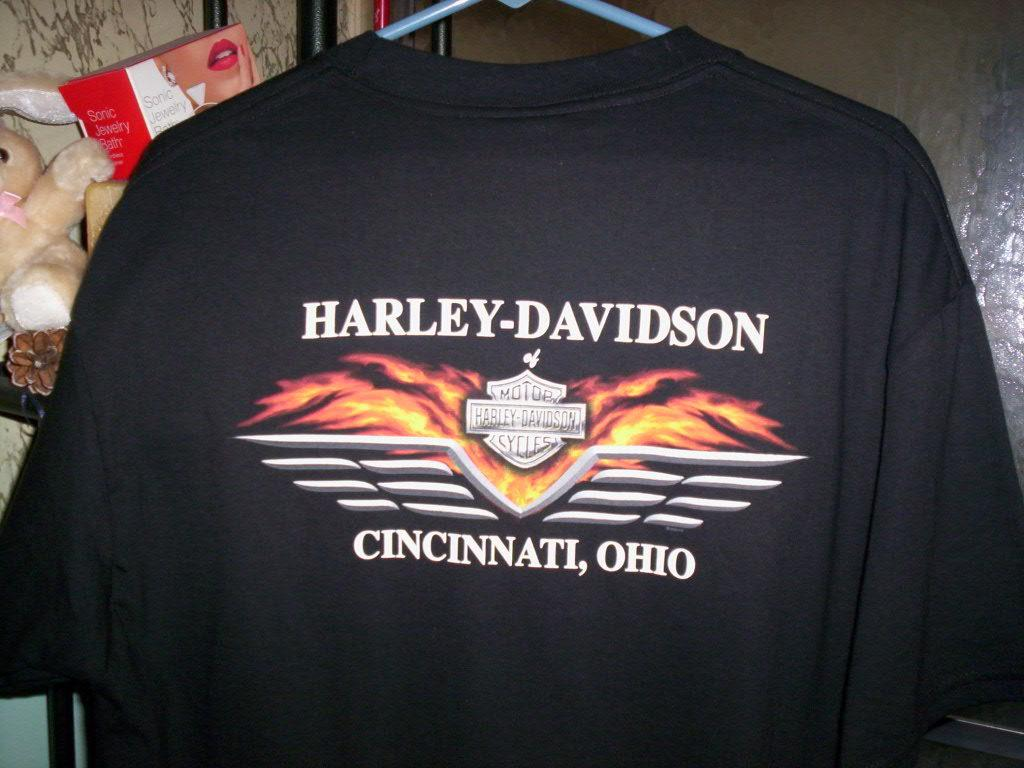<image>
Create a compact narrative representing the image presented. A black Harley Davidson t-shirt from Cincinnati Ohio 